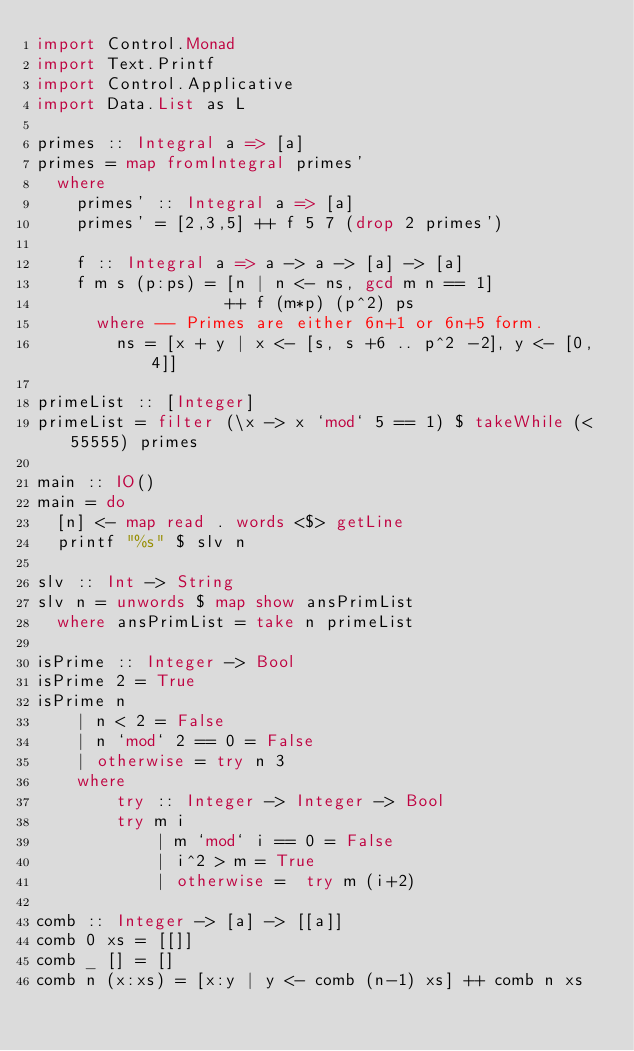Convert code to text. <code><loc_0><loc_0><loc_500><loc_500><_Haskell_>import Control.Monad
import Text.Printf
import Control.Applicative
import Data.List as L

primes :: Integral a => [a]
primes = map fromIntegral primes'
  where
    primes' :: Integral a => [a]
    primes' = [2,3,5] ++ f 5 7 (drop 2 primes')

    f :: Integral a => a -> a -> [a] -> [a]
    f m s (p:ps) = [n | n <- ns, gcd m n == 1]
                   ++ f (m*p) (p^2) ps
      where -- Primes are either 6n+1 or 6n+5 form.
        ns = [x + y | x <- [s, s +6 .. p^2 -2], y <- [0, 4]]

primeList :: [Integer]
primeList = filter (\x -> x `mod` 5 == 1) $ takeWhile (< 55555) primes

main :: IO()
main = do
  [n] <- map read . words <$> getLine
  printf "%s" $ slv n

slv :: Int -> String
slv n = unwords $ map show ansPrimList
  where ansPrimList = take n primeList

isPrime :: Integer -> Bool
isPrime 2 = True
isPrime n
    | n < 2 = False
    | n `mod` 2 == 0 = False
    | otherwise = try n 3
    where
        try :: Integer -> Integer -> Bool
        try m i
            | m `mod` i == 0 = False
            | i^2 > m = True
            | otherwise =  try m (i+2)

comb :: Integer -> [a] -> [[a]]
comb 0 xs = [[]]
comb _ [] = []
comb n (x:xs) = [x:y | y <- comb (n-1) xs] ++ comb n xs</code> 